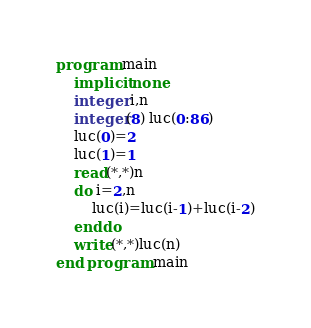<code> <loc_0><loc_0><loc_500><loc_500><_FORTRAN_>program main
	implicit none
	integer i,n
	integer(8) luc(0:86)
	luc(0)=2
	luc(1)=1
	read(*,*)n
	do i=2,n
		luc(i)=luc(i-1)+luc(i-2)
	enddo
	write(*,*)luc(n)
end program main
</code> 